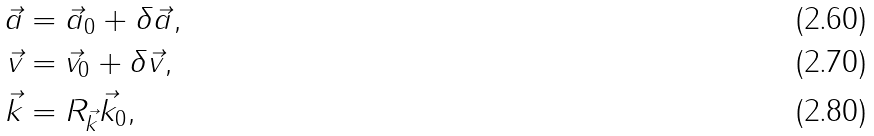Convert formula to latex. <formula><loc_0><loc_0><loc_500><loc_500>\vec { a } & = \vec { a } _ { 0 } + \delta \vec { a } , \\ \vec { v } & = \vec { v } _ { 0 } + \delta \vec { v } , \\ \vec { k } & = R _ { \vec { k } } \vec { k } _ { 0 } ,</formula> 